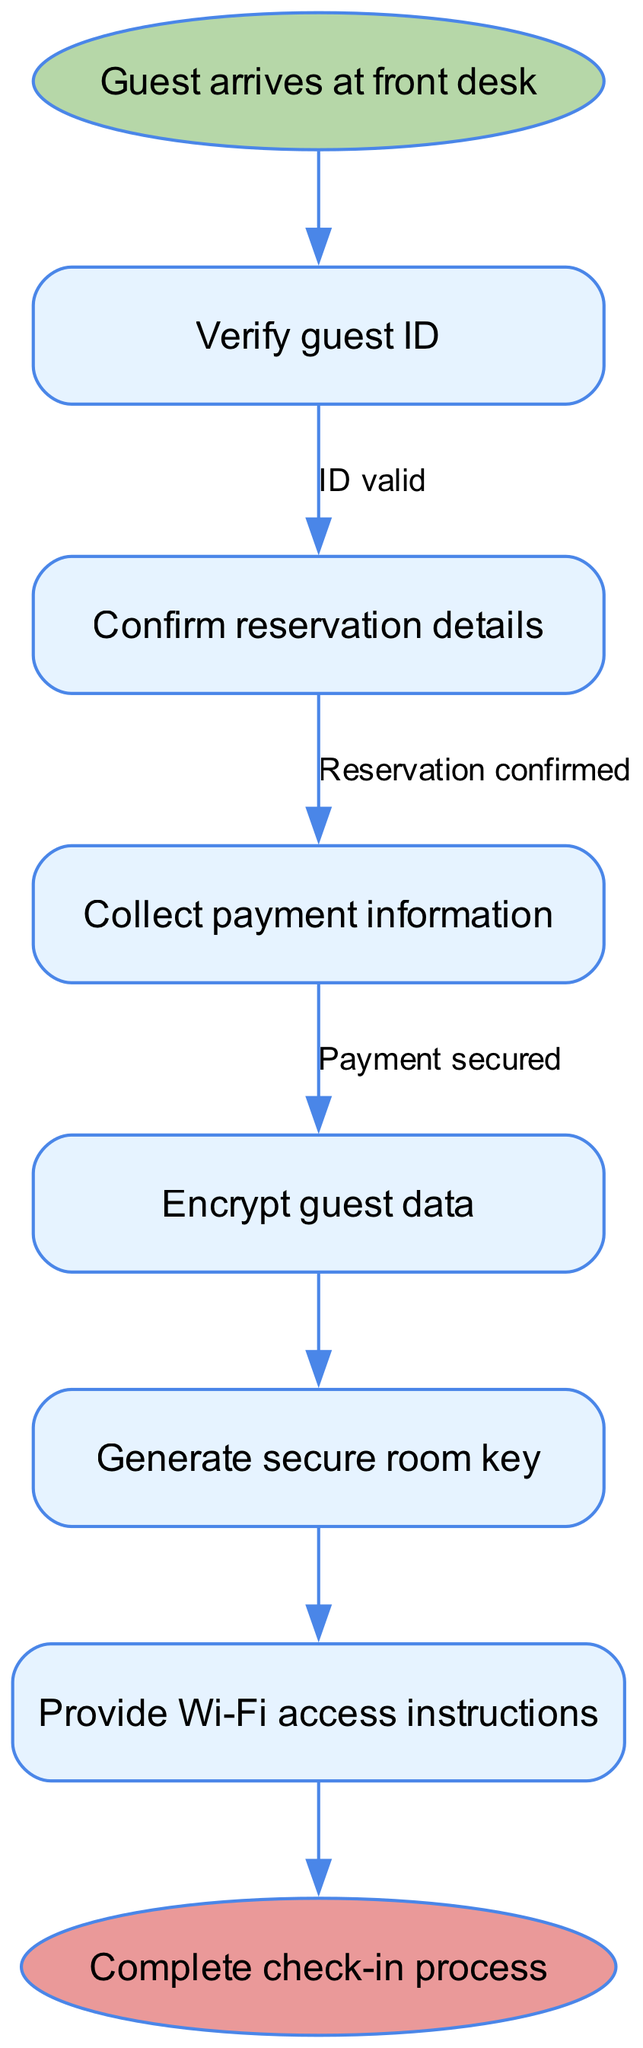What is the first step in the guest check-in security procedure? The first step is labeled as "Guest arrives at front desk," indicating the initiation of the check-in process.
Answer: Guest arrives at front desk How many nodes are in the diagram? The diagram consists of 7 nodes, which include the start, end, and 5 procedural steps.
Answer: 7 What is the last step before completing the check-in process? The last step before completion is "Provide Wi-Fi access instructions," which directly connects to the end node of the diagram.
Answer: Provide Wi-Fi access instructions What happens after verifying guest ID? After verifying guest ID, the next step is to "Confirm reservation details," indicating that the validation leads to confirming the guest's reservation.
Answer: Confirm reservation details How many edges are present in the diagram? There are 6 edges in the diagram that connect the various procedural steps, indicating the flow of actions taken during check-in.
Answer: 6 If the payment is secured, what is the following step? After securing payment, the next step is to "Encrypt guest data," which ensures that the guest’s information is protected.
Answer: Encrypt guest data What does the edge between "Collect payment information" and "Encrypt guest data" signify? The edge signifies that after payment information is collected and confirmed as secure, the next action is to encrypt the guest's data for security.
Answer: Encrypt guest data What type of shape is used to denote the starting point in the diagram? The starting point is represented with an oval shape, indicating the beginning of the flow chart.
Answer: Oval What confirmation is required before collecting payment information? "Reservation confirmed" is required before collecting payment information, showing the necessity for prior verification of the guest's booking.
Answer: Reservation confirmed 